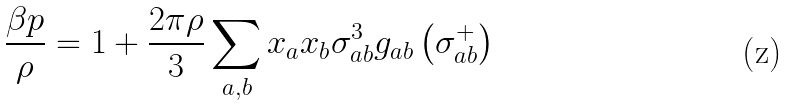Convert formula to latex. <formula><loc_0><loc_0><loc_500><loc_500>\frac { \beta p } { \rho } = 1 + \frac { 2 \pi \rho } { 3 } \sum _ { a , b } x _ { a } x _ { b } \sigma _ { a b } ^ { 3 } g _ { a b } \left ( \sigma _ { a b } ^ { + } \right )</formula> 